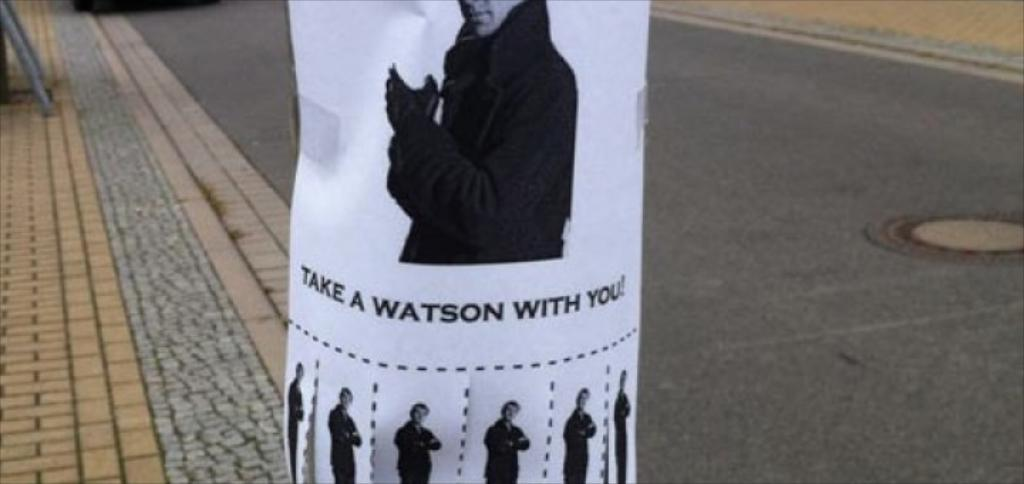What is present in the image? There is a poster in the image. What can be seen on the poster? There are people depicted on the poster. What can be seen in the background of the image? There is a road visible in the background of the image. Are there any fairies flying around the people on the poster? There is no mention of fairies in the image, and they are not depicted on the poster. 